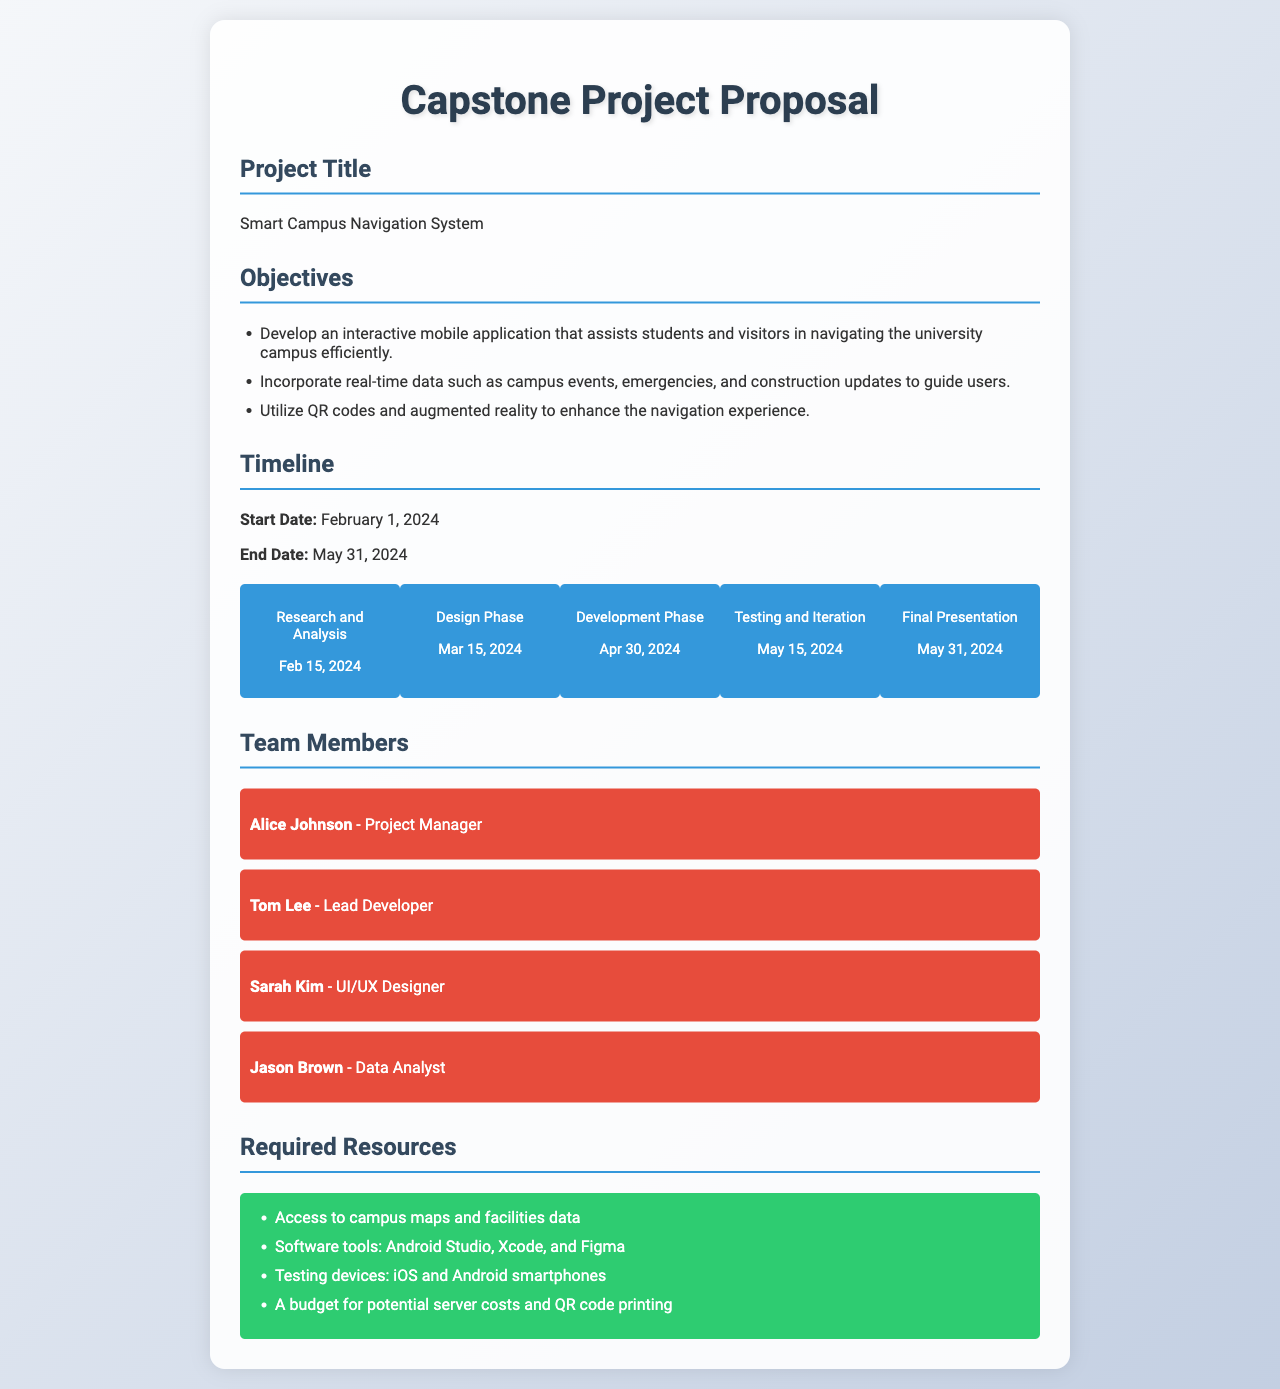What is the project title? The project title is stated at the beginning of the document.
Answer: Smart Campus Navigation System What is the start date of the project? The start date is clearly mentioned in the timeline section.
Answer: February 1, 2024 Who is the Project Manager? The role and name of the team member are provided in the team members section.
Answer: Alice Johnson What milestone occurs on March 15, 2024? This requires looking at the timeline's content for specific dates and associated milestones.
Answer: Design Phase How many objectives are listed in the proposal? The objectives section outlines specific goals for the project; counting the list provides the answer.
Answer: 3 What software tools are required? The required resources section lists the necessary tools for the project.
Answer: Android Studio, Xcode, and Figma What is the end date of the project? The end date is also provided in the timeline section of the document.
Answer: May 31, 2024 Who is the Lead Developer? The team member roles specified in the document include the Lead Developer’s name.
Answer: Tom Lee How many phases are there in the timeline? The timeline lays out specific milestones, which indicates the phases of the project.
Answer: 5 